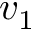Convert formula to latex. <formula><loc_0><loc_0><loc_500><loc_500>v _ { 1 }</formula> 